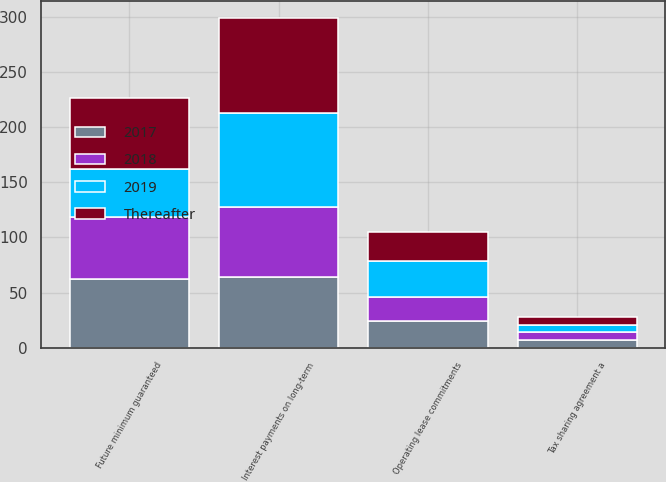Convert chart. <chart><loc_0><loc_0><loc_500><loc_500><stacked_bar_chart><ecel><fcel>Interest payments on long-term<fcel>Operating lease commitments<fcel>Future minimum guaranteed<fcel>Tax sharing agreement a<nl><fcel>2019<fcel>85.8<fcel>32.8<fcel>43.6<fcel>6.4<nl><fcel>Thereafter<fcel>85.8<fcel>26.7<fcel>64.6<fcel>6.7<nl><fcel>2017<fcel>63.8<fcel>24.3<fcel>62.3<fcel>7<nl><fcel>2018<fcel>63.8<fcel>21.6<fcel>56.2<fcel>7.6<nl></chart> 